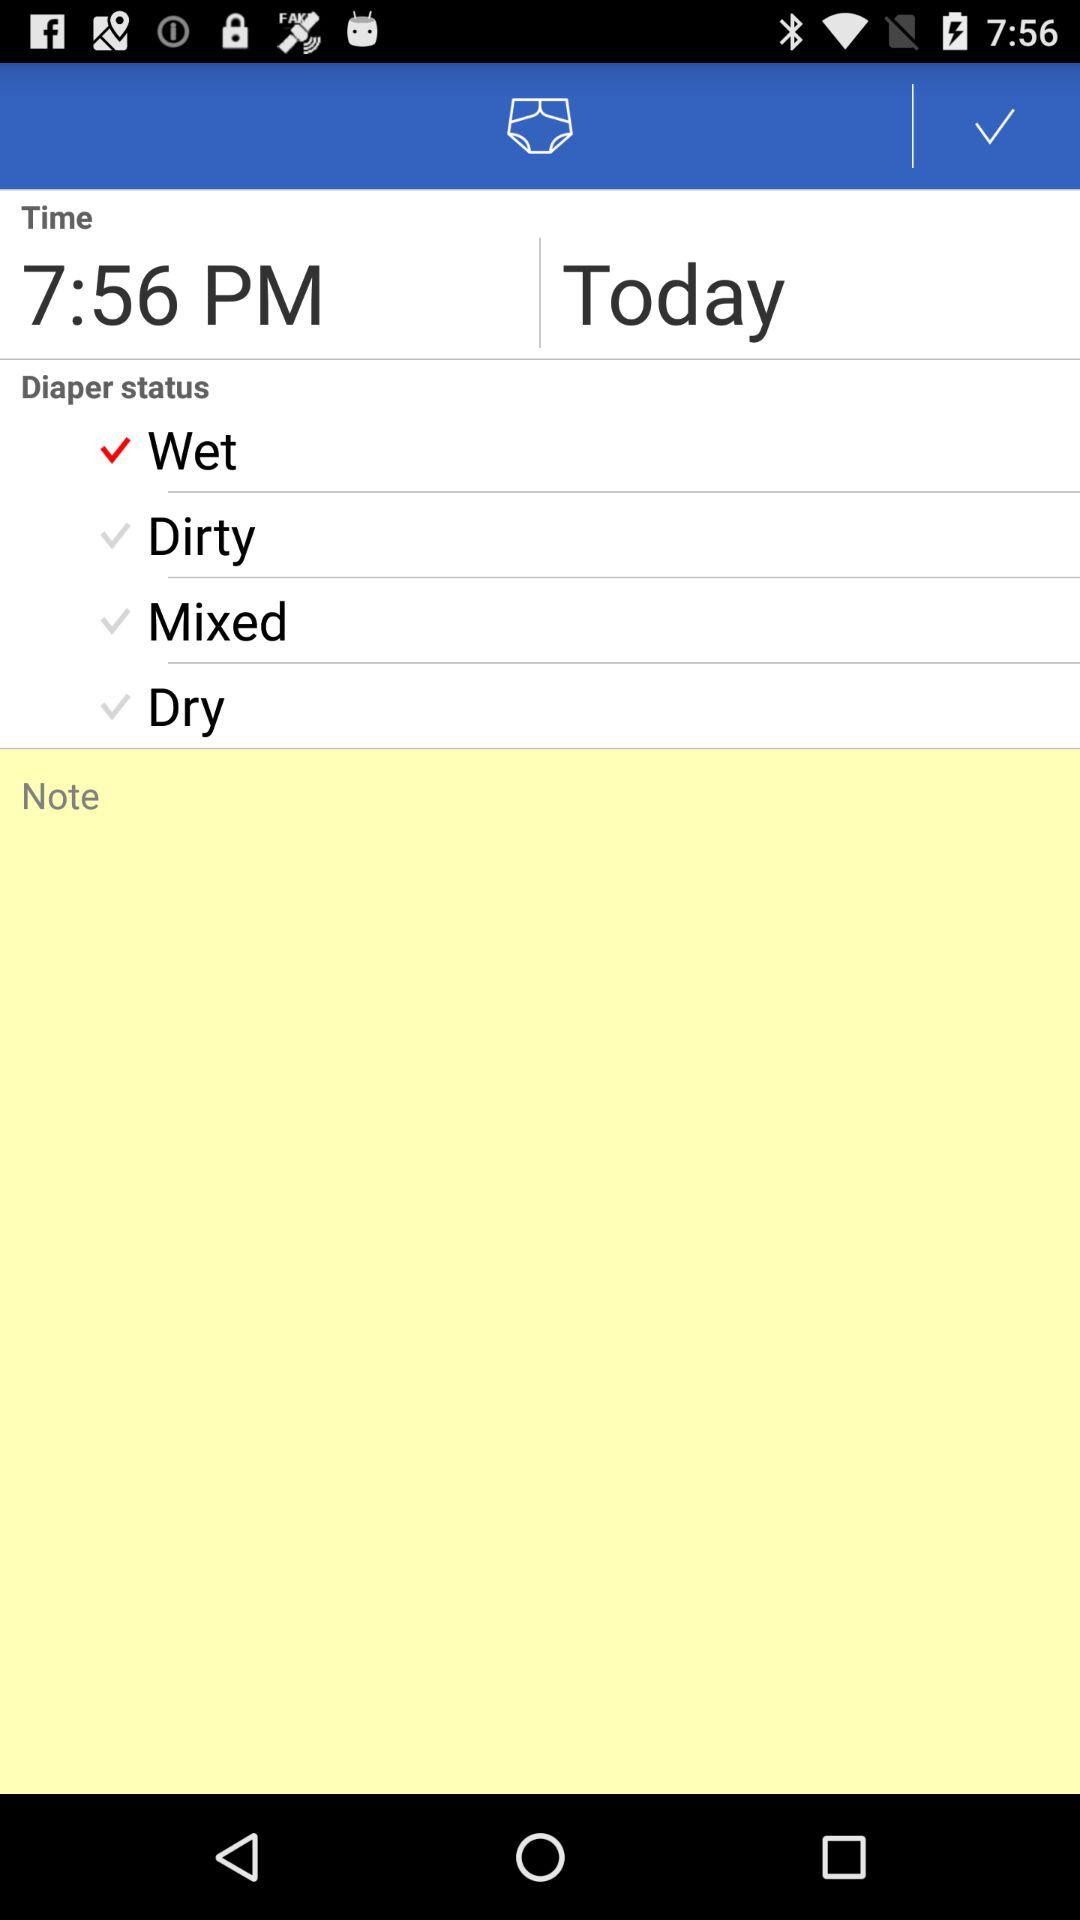How many diaper statuses are there?
Answer the question using a single word or phrase. 4 